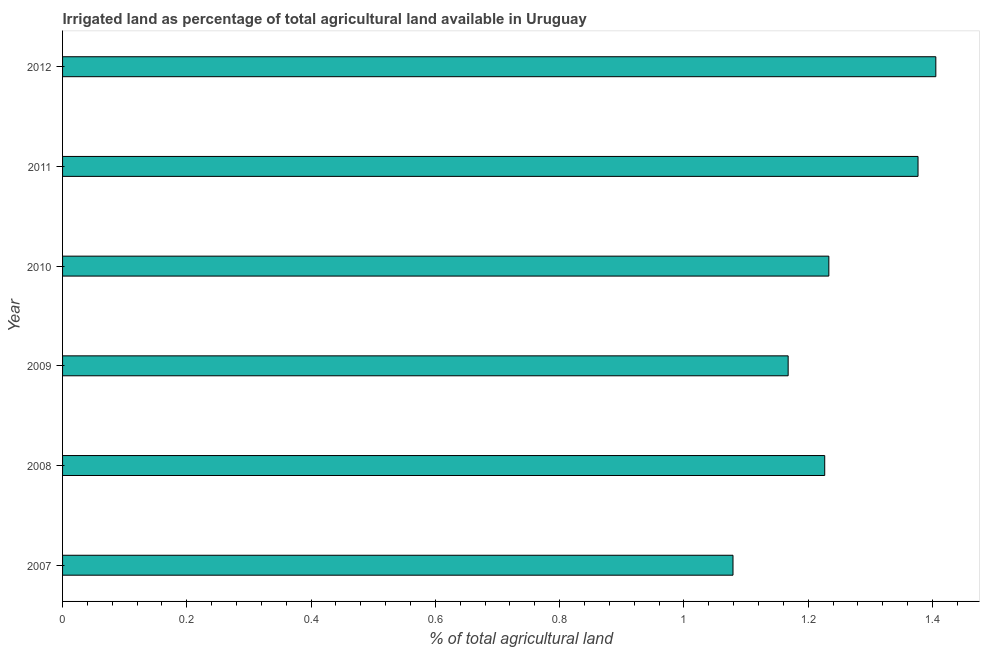Does the graph contain any zero values?
Offer a terse response. No. Does the graph contain grids?
Offer a very short reply. No. What is the title of the graph?
Your answer should be very brief. Irrigated land as percentage of total agricultural land available in Uruguay. What is the label or title of the X-axis?
Ensure brevity in your answer.  % of total agricultural land. What is the percentage of agricultural irrigated land in 2008?
Ensure brevity in your answer.  1.23. Across all years, what is the maximum percentage of agricultural irrigated land?
Give a very brief answer. 1.41. Across all years, what is the minimum percentage of agricultural irrigated land?
Provide a succinct answer. 1.08. What is the sum of the percentage of agricultural irrigated land?
Provide a short and direct response. 7.49. What is the difference between the percentage of agricultural irrigated land in 2009 and 2012?
Your answer should be very brief. -0.24. What is the average percentage of agricultural irrigated land per year?
Your response must be concise. 1.25. What is the median percentage of agricultural irrigated land?
Your response must be concise. 1.23. Do a majority of the years between 2009 and 2012 (inclusive) have percentage of agricultural irrigated land greater than 0.12 %?
Keep it short and to the point. Yes. What is the ratio of the percentage of agricultural irrigated land in 2009 to that in 2011?
Your answer should be very brief. 0.85. Is the percentage of agricultural irrigated land in 2007 less than that in 2011?
Ensure brevity in your answer.  Yes. Is the difference between the percentage of agricultural irrigated land in 2007 and 2009 greater than the difference between any two years?
Your answer should be very brief. No. What is the difference between the highest and the second highest percentage of agricultural irrigated land?
Ensure brevity in your answer.  0.03. What is the difference between the highest and the lowest percentage of agricultural irrigated land?
Your answer should be compact. 0.33. In how many years, is the percentage of agricultural irrigated land greater than the average percentage of agricultural irrigated land taken over all years?
Provide a short and direct response. 2. Are all the bars in the graph horizontal?
Your answer should be very brief. Yes. What is the % of total agricultural land in 2007?
Your response must be concise. 1.08. What is the % of total agricultural land in 2008?
Offer a very short reply. 1.23. What is the % of total agricultural land of 2009?
Ensure brevity in your answer.  1.17. What is the % of total agricultural land in 2010?
Keep it short and to the point. 1.23. What is the % of total agricultural land of 2011?
Make the answer very short. 1.38. What is the % of total agricultural land of 2012?
Give a very brief answer. 1.41. What is the difference between the % of total agricultural land in 2007 and 2008?
Your answer should be compact. -0.15. What is the difference between the % of total agricultural land in 2007 and 2009?
Offer a very short reply. -0.09. What is the difference between the % of total agricultural land in 2007 and 2010?
Ensure brevity in your answer.  -0.15. What is the difference between the % of total agricultural land in 2007 and 2011?
Offer a very short reply. -0.3. What is the difference between the % of total agricultural land in 2007 and 2012?
Your response must be concise. -0.33. What is the difference between the % of total agricultural land in 2008 and 2009?
Your answer should be compact. 0.06. What is the difference between the % of total agricultural land in 2008 and 2010?
Provide a succinct answer. -0.01. What is the difference between the % of total agricultural land in 2008 and 2011?
Keep it short and to the point. -0.15. What is the difference between the % of total agricultural land in 2008 and 2012?
Give a very brief answer. -0.18. What is the difference between the % of total agricultural land in 2009 and 2010?
Offer a very short reply. -0.07. What is the difference between the % of total agricultural land in 2009 and 2011?
Provide a short and direct response. -0.21. What is the difference between the % of total agricultural land in 2009 and 2012?
Keep it short and to the point. -0.24. What is the difference between the % of total agricultural land in 2010 and 2011?
Provide a short and direct response. -0.14. What is the difference between the % of total agricultural land in 2010 and 2012?
Keep it short and to the point. -0.17. What is the difference between the % of total agricultural land in 2011 and 2012?
Your response must be concise. -0.03. What is the ratio of the % of total agricultural land in 2007 to that in 2008?
Make the answer very short. 0.88. What is the ratio of the % of total agricultural land in 2007 to that in 2009?
Provide a succinct answer. 0.92. What is the ratio of the % of total agricultural land in 2007 to that in 2010?
Provide a short and direct response. 0.88. What is the ratio of the % of total agricultural land in 2007 to that in 2011?
Provide a succinct answer. 0.78. What is the ratio of the % of total agricultural land in 2007 to that in 2012?
Your answer should be compact. 0.77. What is the ratio of the % of total agricultural land in 2008 to that in 2010?
Your response must be concise. 0.99. What is the ratio of the % of total agricultural land in 2008 to that in 2011?
Offer a very short reply. 0.89. What is the ratio of the % of total agricultural land in 2008 to that in 2012?
Your answer should be very brief. 0.87. What is the ratio of the % of total agricultural land in 2009 to that in 2010?
Offer a terse response. 0.95. What is the ratio of the % of total agricultural land in 2009 to that in 2011?
Offer a very short reply. 0.85. What is the ratio of the % of total agricultural land in 2009 to that in 2012?
Provide a short and direct response. 0.83. What is the ratio of the % of total agricultural land in 2010 to that in 2011?
Keep it short and to the point. 0.9. What is the ratio of the % of total agricultural land in 2010 to that in 2012?
Your answer should be very brief. 0.88. 